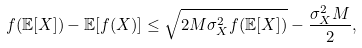<formula> <loc_0><loc_0><loc_500><loc_500>f ( \mathbb { E } [ X ] ) - \mathbb { E } [ f ( X ) ] \leq \sqrt { 2 M \sigma _ { X } ^ { 2 } f ( \mathbb { E } [ X ] ) } - \frac { \sigma _ { X } ^ { 2 } M } { 2 } ,</formula> 